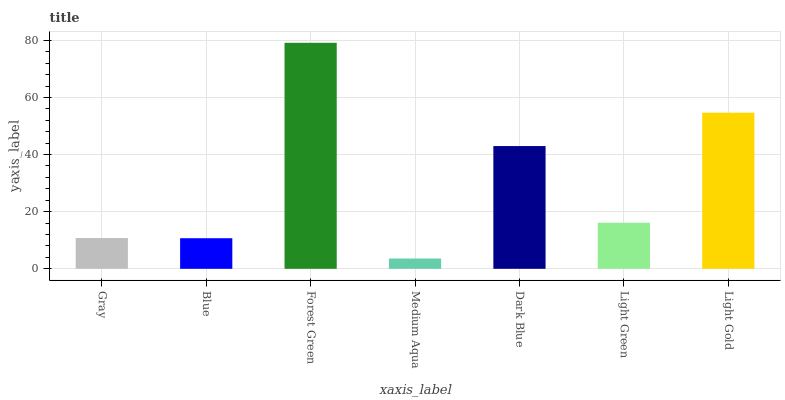Is Medium Aqua the minimum?
Answer yes or no. Yes. Is Forest Green the maximum?
Answer yes or no. Yes. Is Blue the minimum?
Answer yes or no. No. Is Blue the maximum?
Answer yes or no. No. Is Gray greater than Blue?
Answer yes or no. Yes. Is Blue less than Gray?
Answer yes or no. Yes. Is Blue greater than Gray?
Answer yes or no. No. Is Gray less than Blue?
Answer yes or no. No. Is Light Green the high median?
Answer yes or no. Yes. Is Light Green the low median?
Answer yes or no. Yes. Is Dark Blue the high median?
Answer yes or no. No. Is Forest Green the low median?
Answer yes or no. No. 